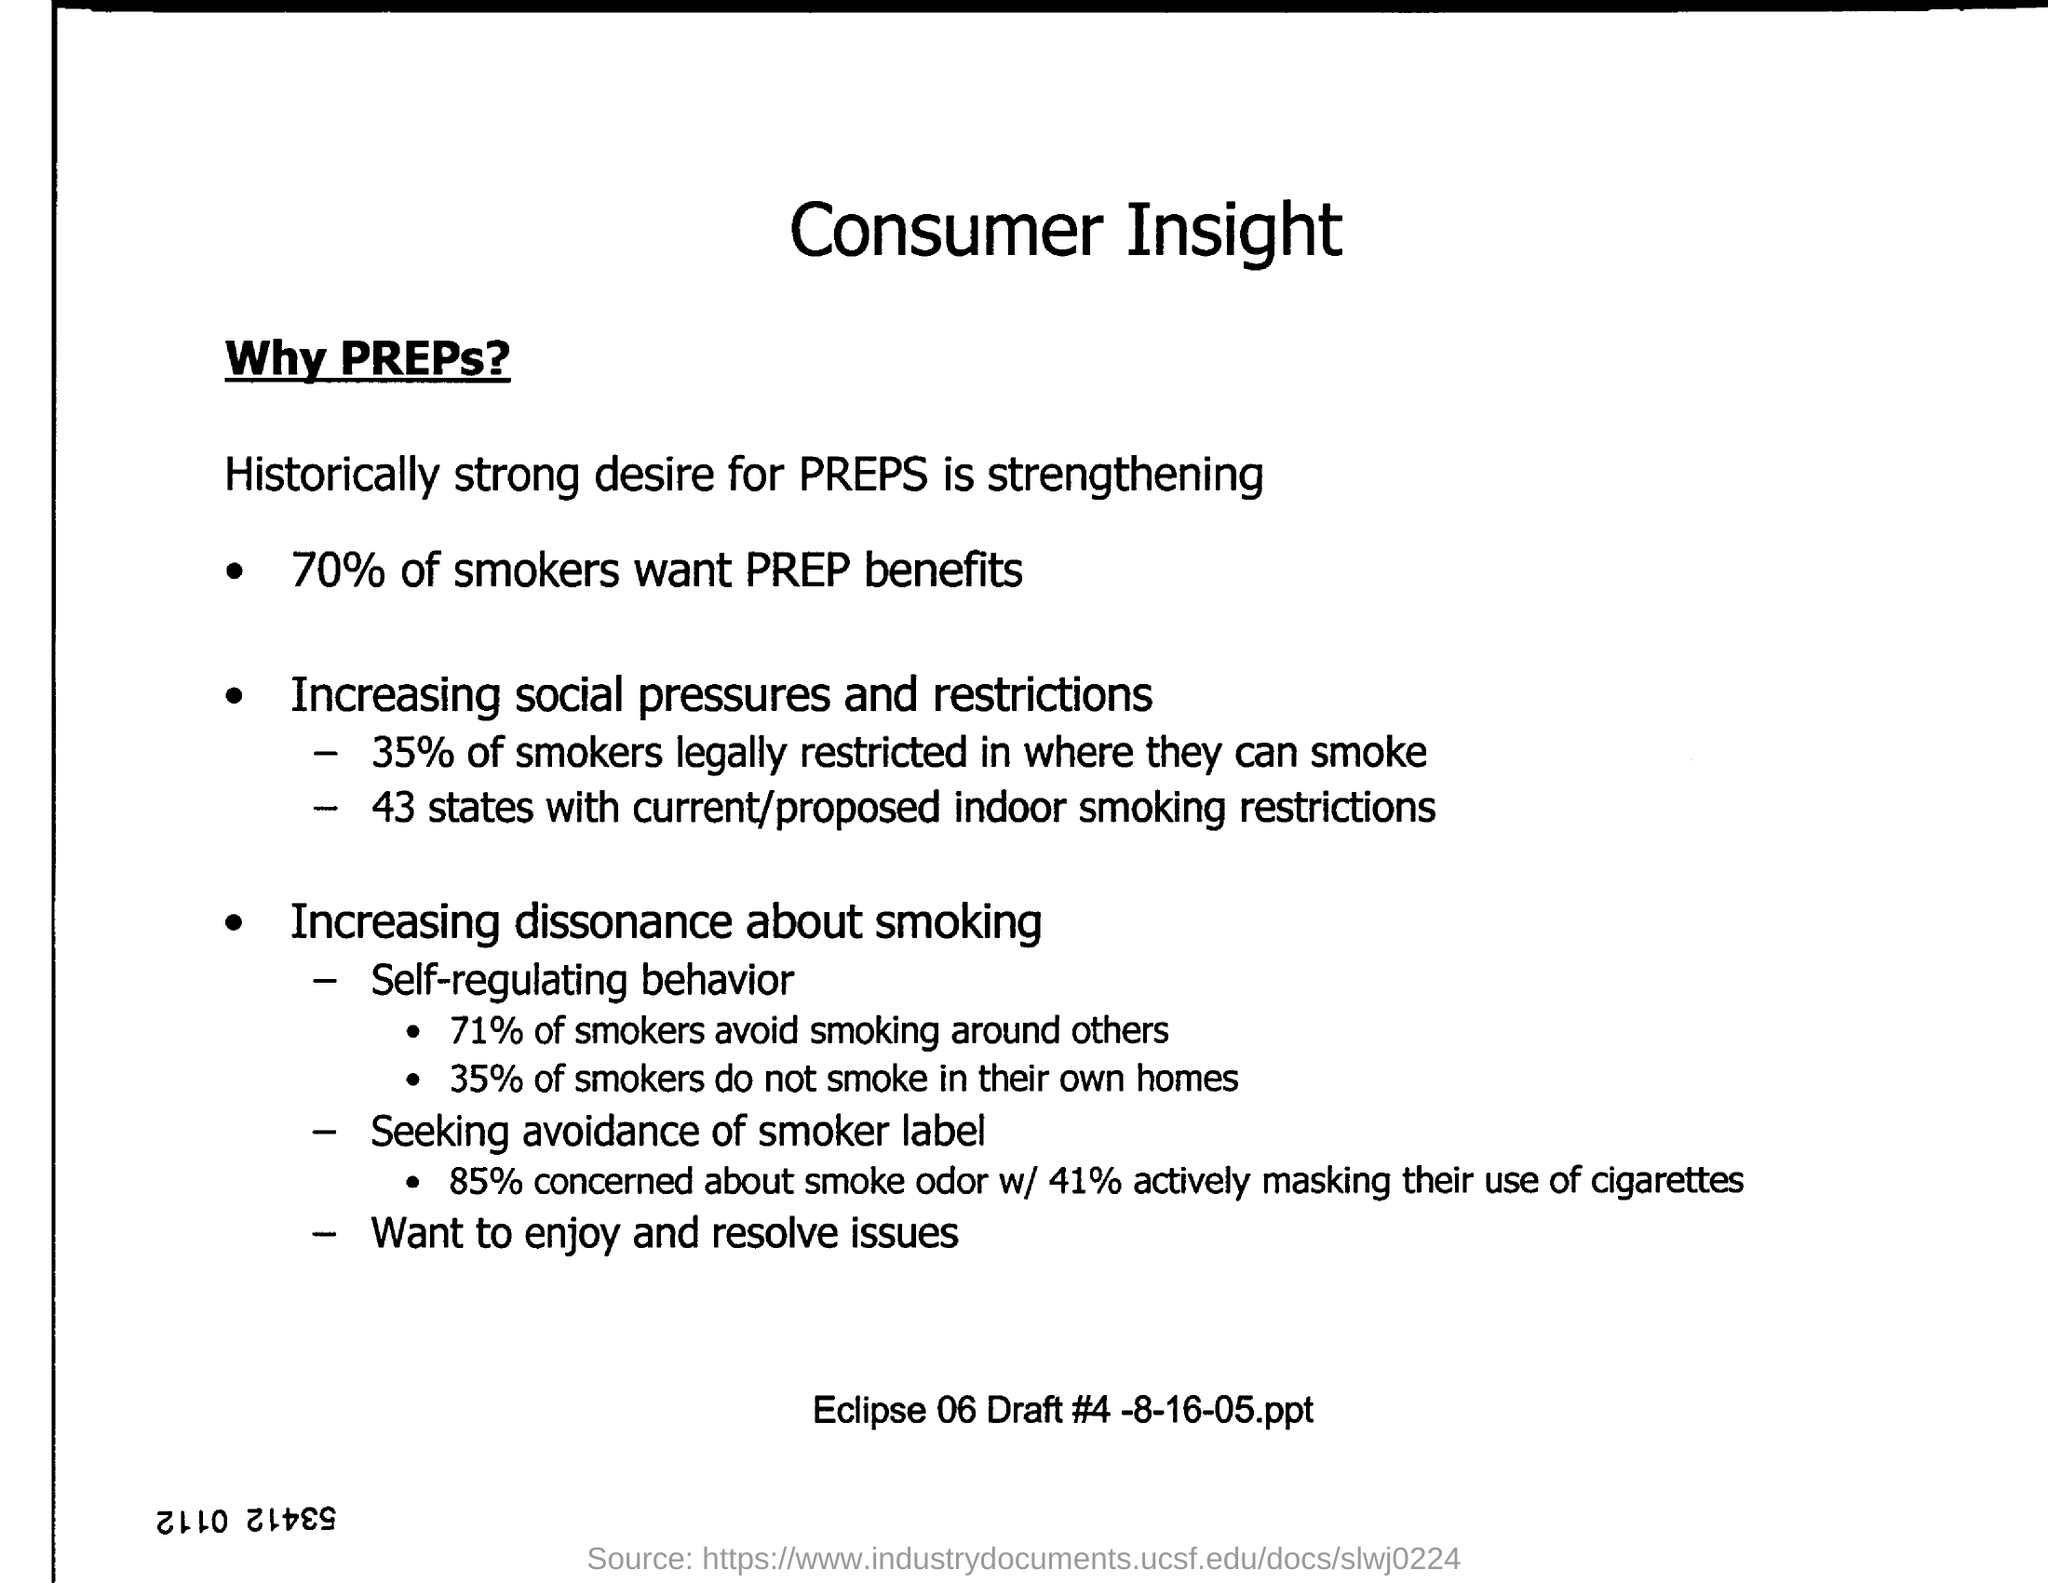Are many smokers legally restricted from smoking indoors, and how does this relate to the number of states with restrictions? The image shows that 35% of smokers are legally restricted from smoking in indoor environments. This figure correlates with the fact that 43 states have imposed or are considering indoor smoking restrictions, pointing to a significant shift in legislation addressing smoking in public spaces. 